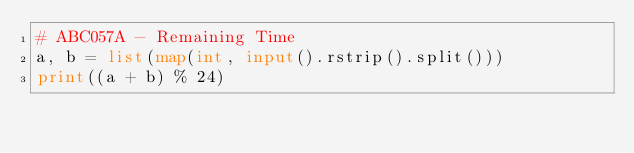<code> <loc_0><loc_0><loc_500><loc_500><_Python_># ABC057A - Remaining Time
a, b = list(map(int, input().rstrip().split()))
print((a + b) % 24)</code> 